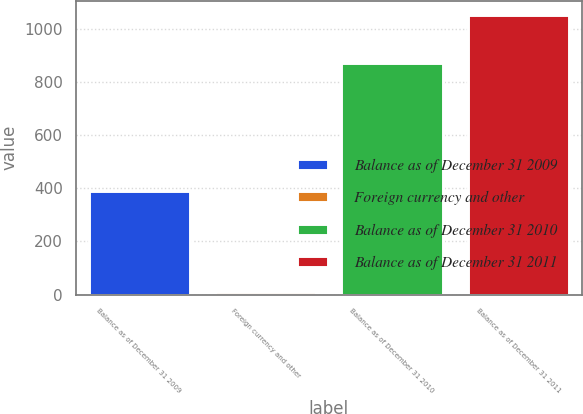Convert chart to OTSL. <chart><loc_0><loc_0><loc_500><loc_500><bar_chart><fcel>Balance as of December 31 2009<fcel>Foreign currency and other<fcel>Balance as of December 31 2010<fcel>Balance as of December 31 2011<nl><fcel>389<fcel>9<fcel>873<fcel>1054<nl></chart> 